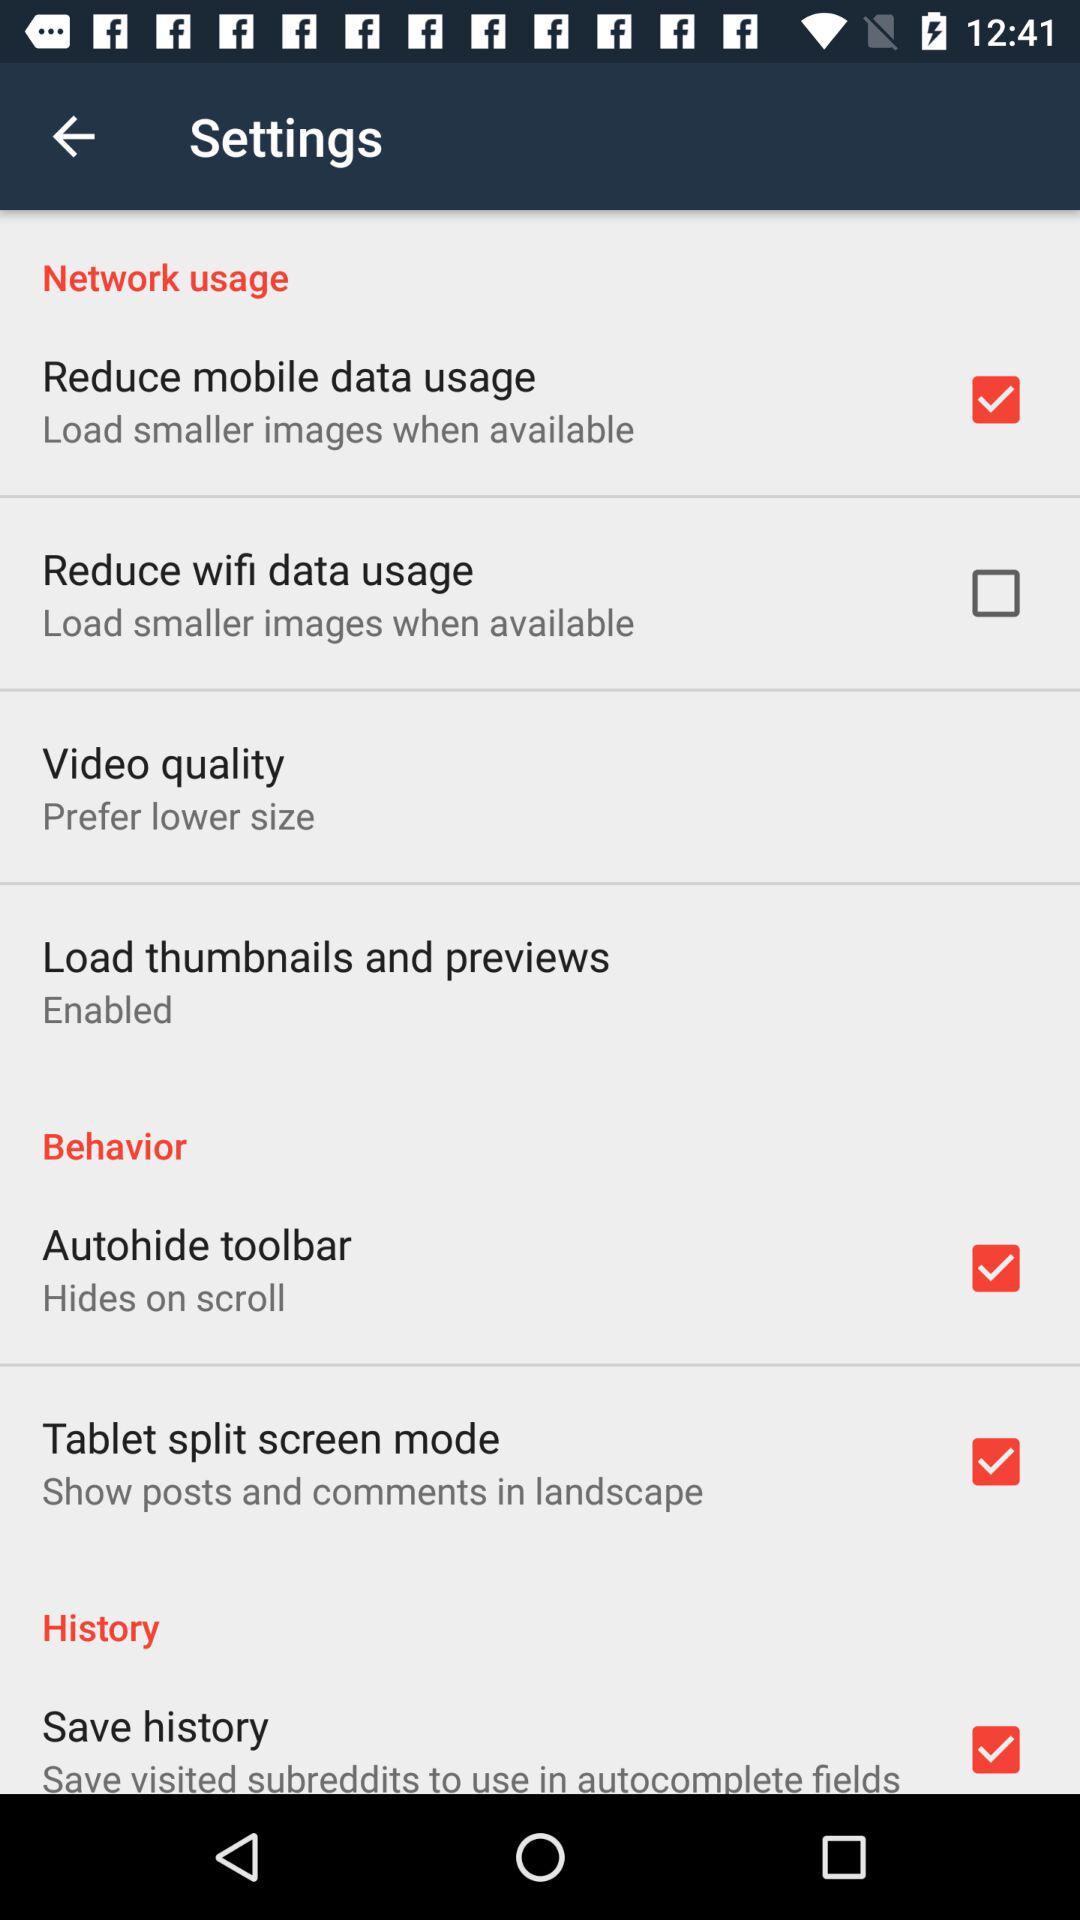Which option is not checked in network usage? The option is "Reduce wifi data usage". 